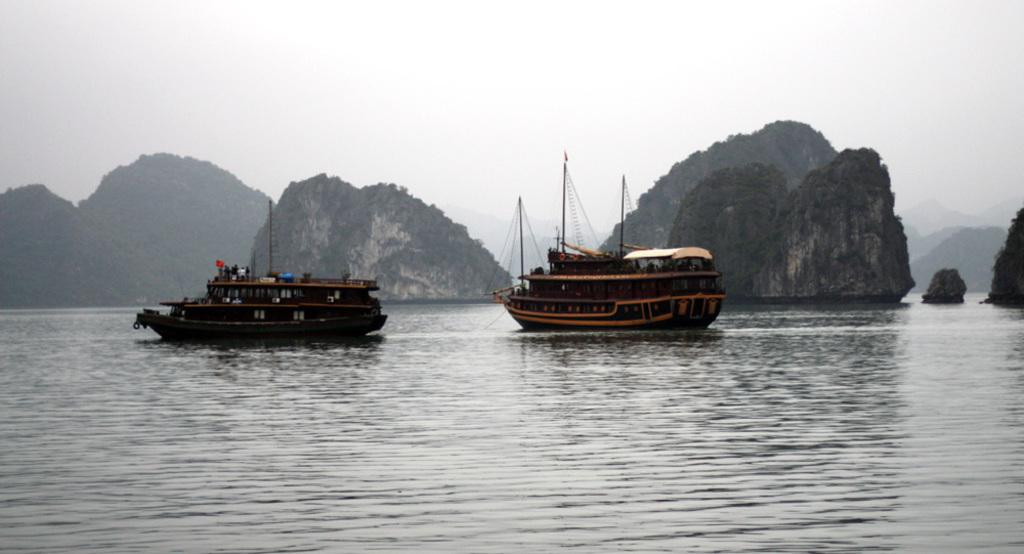What is the primary element in the image? There is water in the image. What can be seen floating on the water? There are brown-colored boats in the water. Are there any people present in the image? Yes, there are people visible in the image. What is the color of the flag in the image? There is a red-colored flag in the image. Is there a volcano erupting in the image? No, there is no volcano present in the image. What type of whip is being used by the people in the image? There is no whip visible in the image; it does not depict any whip-related activities. 